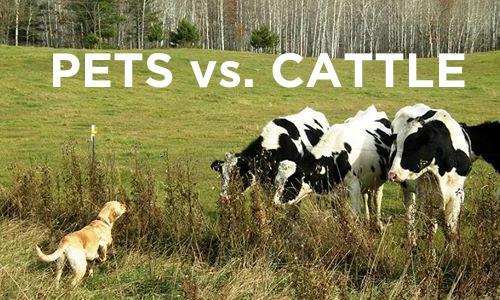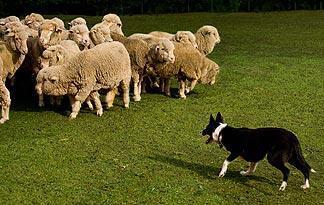The first image is the image on the left, the second image is the image on the right. Assess this claim about the two images: "An image shows a dog at the right herding no more than three sheep, which are at the left.". Correct or not? Answer yes or no. No. 